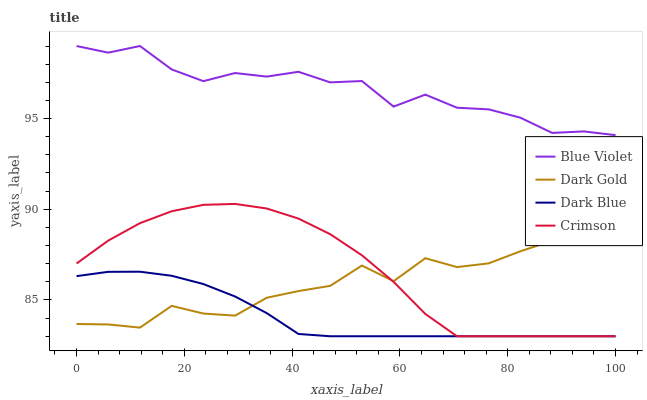Does Dark Blue have the minimum area under the curve?
Answer yes or no. Yes. Does Blue Violet have the maximum area under the curve?
Answer yes or no. Yes. Does Blue Violet have the minimum area under the curve?
Answer yes or no. No. Does Dark Blue have the maximum area under the curve?
Answer yes or no. No. Is Dark Blue the smoothest?
Answer yes or no. Yes. Is Dark Gold the roughest?
Answer yes or no. Yes. Is Blue Violet the smoothest?
Answer yes or no. No. Is Blue Violet the roughest?
Answer yes or no. No. Does Crimson have the lowest value?
Answer yes or no. Yes. Does Blue Violet have the lowest value?
Answer yes or no. No. Does Blue Violet have the highest value?
Answer yes or no. Yes. Does Dark Blue have the highest value?
Answer yes or no. No. Is Crimson less than Blue Violet?
Answer yes or no. Yes. Is Blue Violet greater than Dark Blue?
Answer yes or no. Yes. Does Dark Gold intersect Dark Blue?
Answer yes or no. Yes. Is Dark Gold less than Dark Blue?
Answer yes or no. No. Is Dark Gold greater than Dark Blue?
Answer yes or no. No. Does Crimson intersect Blue Violet?
Answer yes or no. No. 